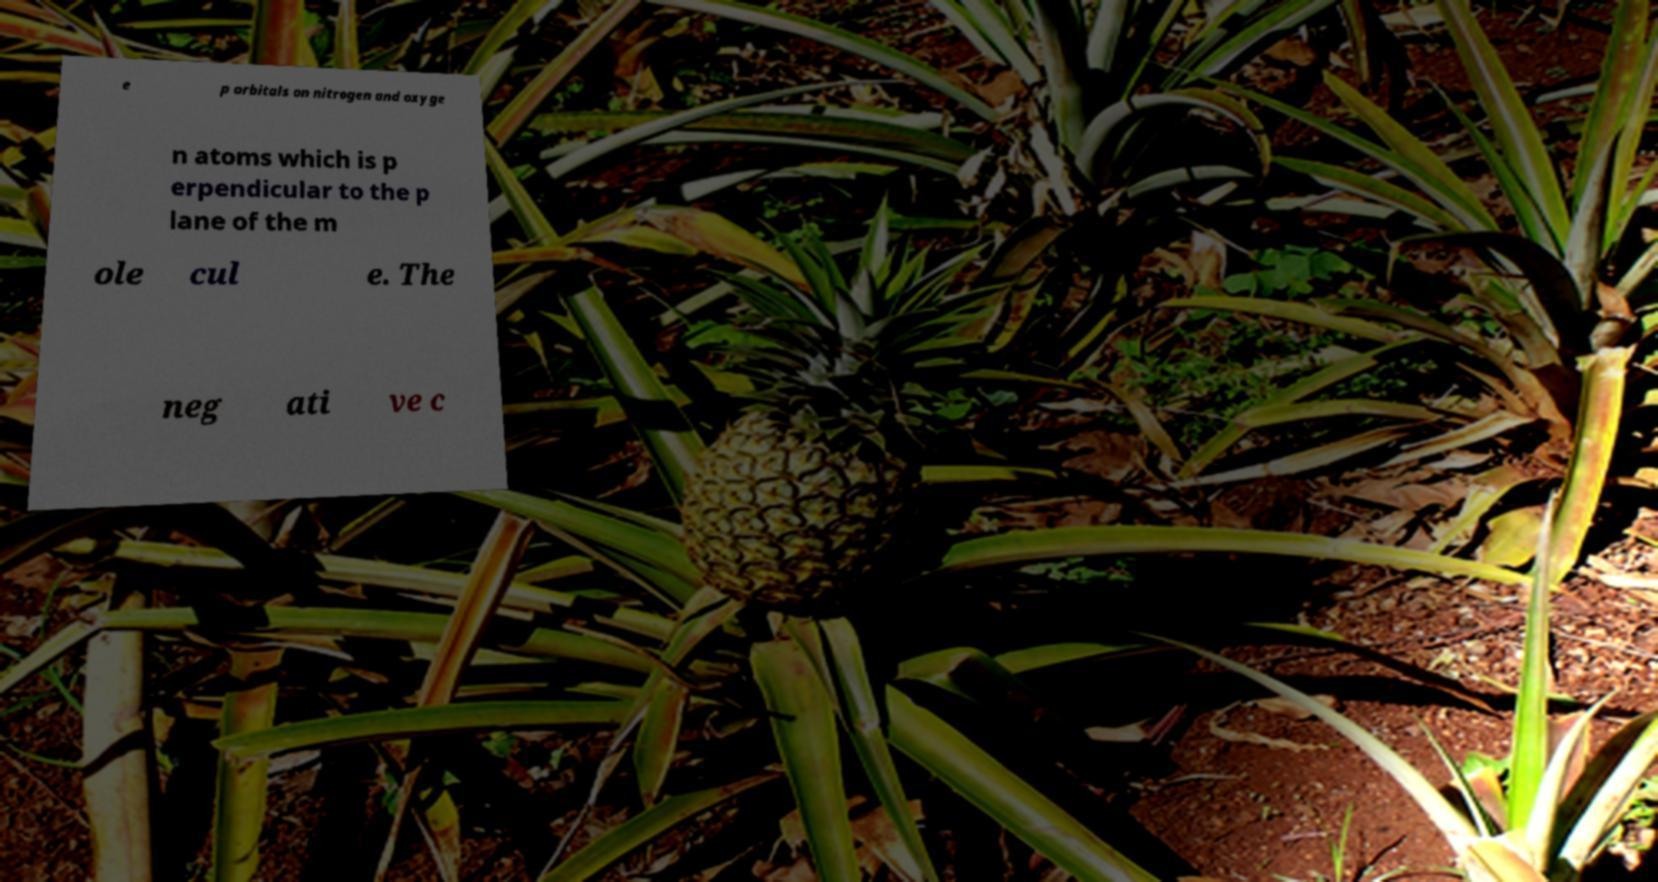What messages or text are displayed in this image? I need them in a readable, typed format. e p orbitals on nitrogen and oxyge n atoms which is p erpendicular to the p lane of the m ole cul e. The neg ati ve c 